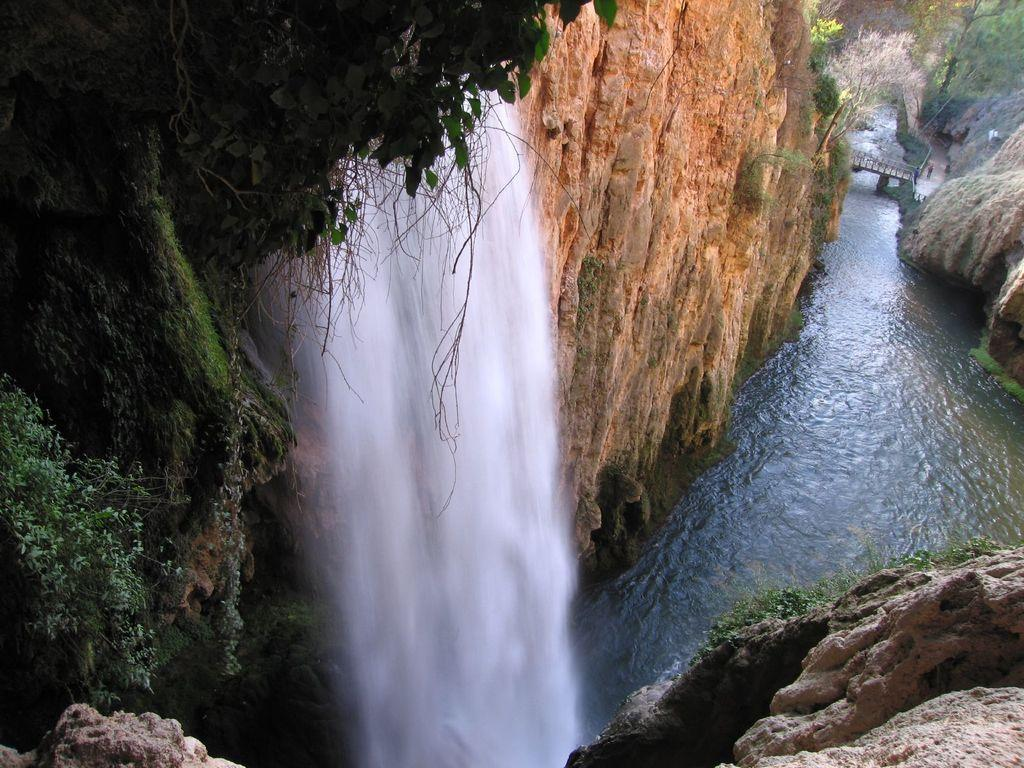What type of natural elements can be seen in the image? There are trees and water visible in the image. What other objects can be seen in the image? There are rocks in the image. What structure is visible in the background of the image? There is a bridge in the background of the image. What type of polish is being applied to the houses in the image? There are no houses present in the image, so there is no polish being applied. 